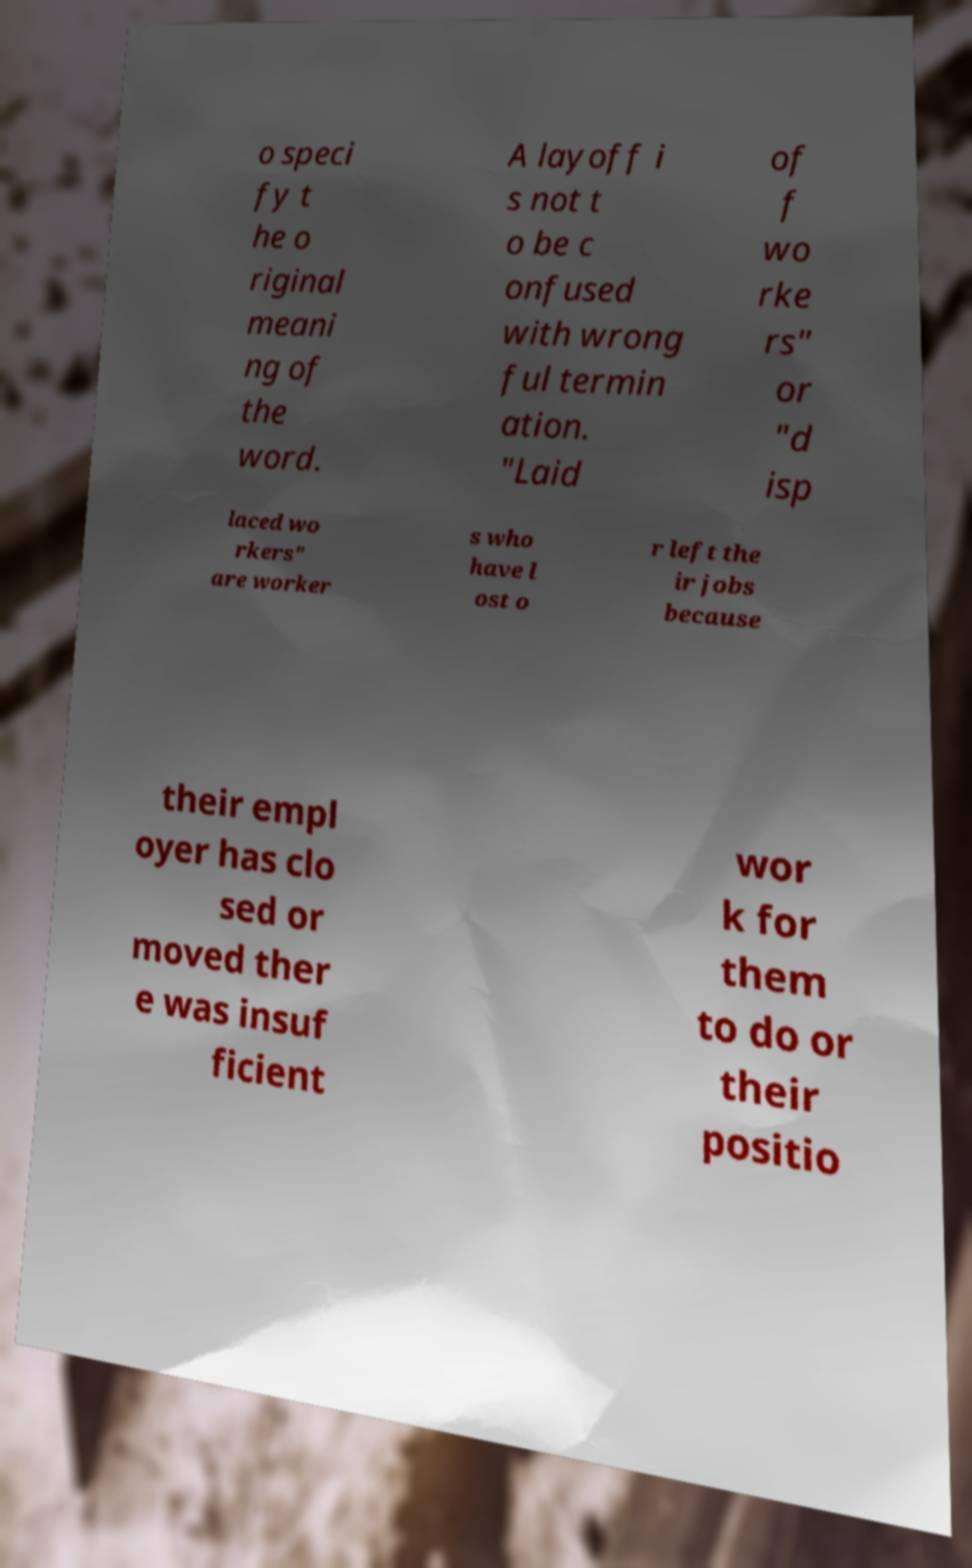Please read and relay the text visible in this image. What does it say? o speci fy t he o riginal meani ng of the word. A layoff i s not t o be c onfused with wrong ful termin ation. "Laid of f wo rke rs" or "d isp laced wo rkers" are worker s who have l ost o r left the ir jobs because their empl oyer has clo sed or moved ther e was insuf ficient wor k for them to do or their positio 